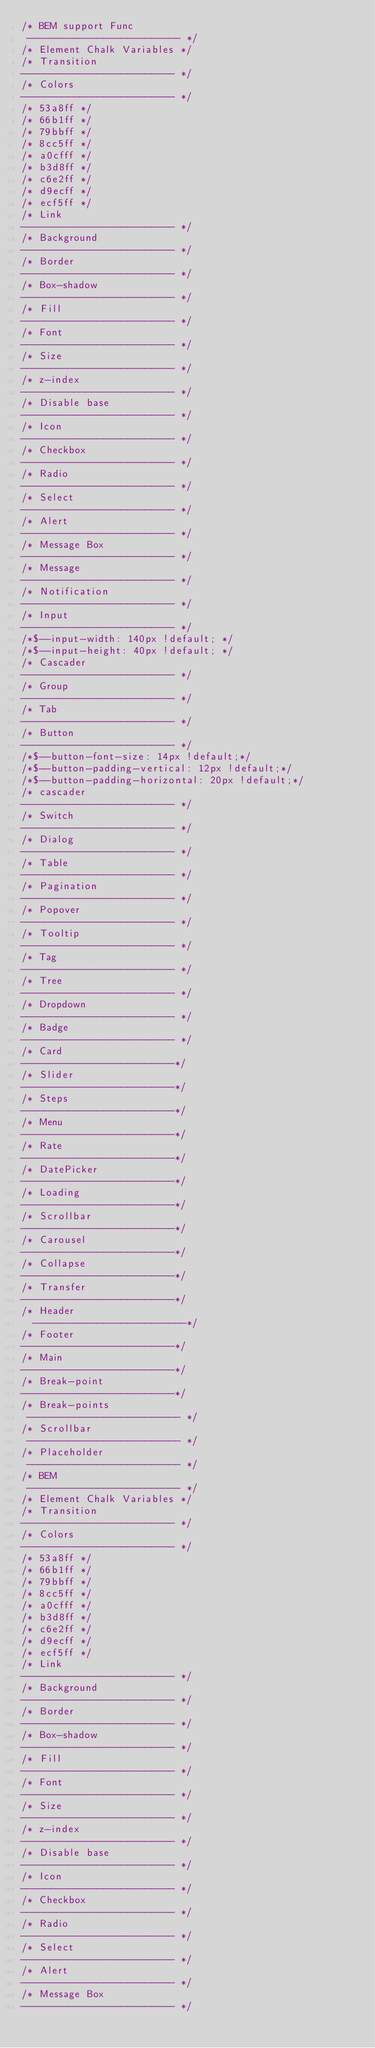<code> <loc_0><loc_0><loc_500><loc_500><_CSS_>/* BEM support Func
 -------------------------- */
/* Element Chalk Variables */
/* Transition
-------------------------- */
/* Colors
-------------------------- */
/* 53a8ff */
/* 66b1ff */
/* 79bbff */
/* 8cc5ff */
/* a0cfff */
/* b3d8ff */
/* c6e2ff */
/* d9ecff */
/* ecf5ff */
/* Link
-------------------------- */
/* Background
-------------------------- */
/* Border
-------------------------- */
/* Box-shadow
-------------------------- */
/* Fill
-------------------------- */
/* Font
-------------------------- */
/* Size
-------------------------- */
/* z-index
-------------------------- */
/* Disable base
-------------------------- */
/* Icon
-------------------------- */
/* Checkbox
-------------------------- */
/* Radio
-------------------------- */
/* Select
-------------------------- */
/* Alert
-------------------------- */
/* Message Box
-------------------------- */
/* Message
-------------------------- */
/* Notification
-------------------------- */
/* Input
-------------------------- */
/*$--input-width: 140px !default; */
/*$--input-height: 40px !default; */
/* Cascader
-------------------------- */
/* Group
-------------------------- */
/* Tab
-------------------------- */
/* Button
-------------------------- */
/*$--button-font-size: 14px !default;*/
/*$--button-padding-vertical: 12px !default;*/
/*$--button-padding-horizontal: 20px !default;*/
/* cascader
-------------------------- */
/* Switch
-------------------------- */
/* Dialog
-------------------------- */
/* Table
-------------------------- */
/* Pagination
-------------------------- */
/* Popover
-------------------------- */
/* Tooltip
-------------------------- */
/* Tag
-------------------------- */
/* Tree
-------------------------- */
/* Dropdown
-------------------------- */
/* Badge
-------------------------- */
/* Card
--------------------------*/
/* Slider
--------------------------*/
/* Steps
--------------------------*/
/* Menu
--------------------------*/
/* Rate
--------------------------*/
/* DatePicker
--------------------------*/
/* Loading
--------------------------*/
/* Scrollbar
--------------------------*/
/* Carousel
--------------------------*/
/* Collapse
--------------------------*/
/* Transfer
--------------------------*/
/* Header
  --------------------------*/
/* Footer
--------------------------*/
/* Main
--------------------------*/
/* Break-point
--------------------------*/
/* Break-points
 -------------------------- */
/* Scrollbar
 -------------------------- */
/* Placeholder
 -------------------------- */
/* BEM
 -------------------------- */
/* Element Chalk Variables */
/* Transition
-------------------------- */
/* Colors
-------------------------- */
/* 53a8ff */
/* 66b1ff */
/* 79bbff */
/* 8cc5ff */
/* a0cfff */
/* b3d8ff */
/* c6e2ff */
/* d9ecff */
/* ecf5ff */
/* Link
-------------------------- */
/* Background
-------------------------- */
/* Border
-------------------------- */
/* Box-shadow
-------------------------- */
/* Fill
-------------------------- */
/* Font
-------------------------- */
/* Size
-------------------------- */
/* z-index
-------------------------- */
/* Disable base
-------------------------- */
/* Icon
-------------------------- */
/* Checkbox
-------------------------- */
/* Radio
-------------------------- */
/* Select
-------------------------- */
/* Alert
-------------------------- */
/* Message Box
-------------------------- */</code> 